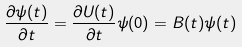<formula> <loc_0><loc_0><loc_500><loc_500>\frac { \partial \psi ( t ) } { \partial t } = \frac { \partial U ( t ) } { \partial t } \psi ( 0 ) = B ( t ) \psi ( t )</formula> 